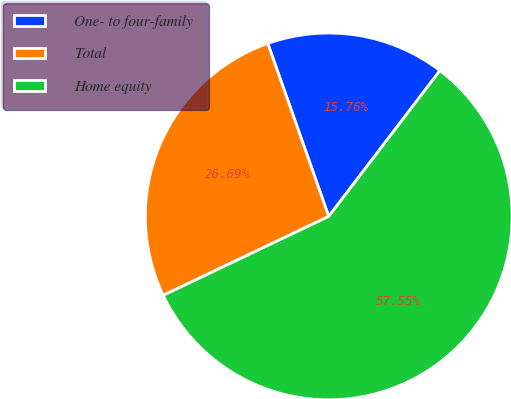<chart> <loc_0><loc_0><loc_500><loc_500><pie_chart><fcel>One- to four-family<fcel>Total<fcel>Home equity<nl><fcel>15.76%<fcel>26.69%<fcel>57.54%<nl></chart> 